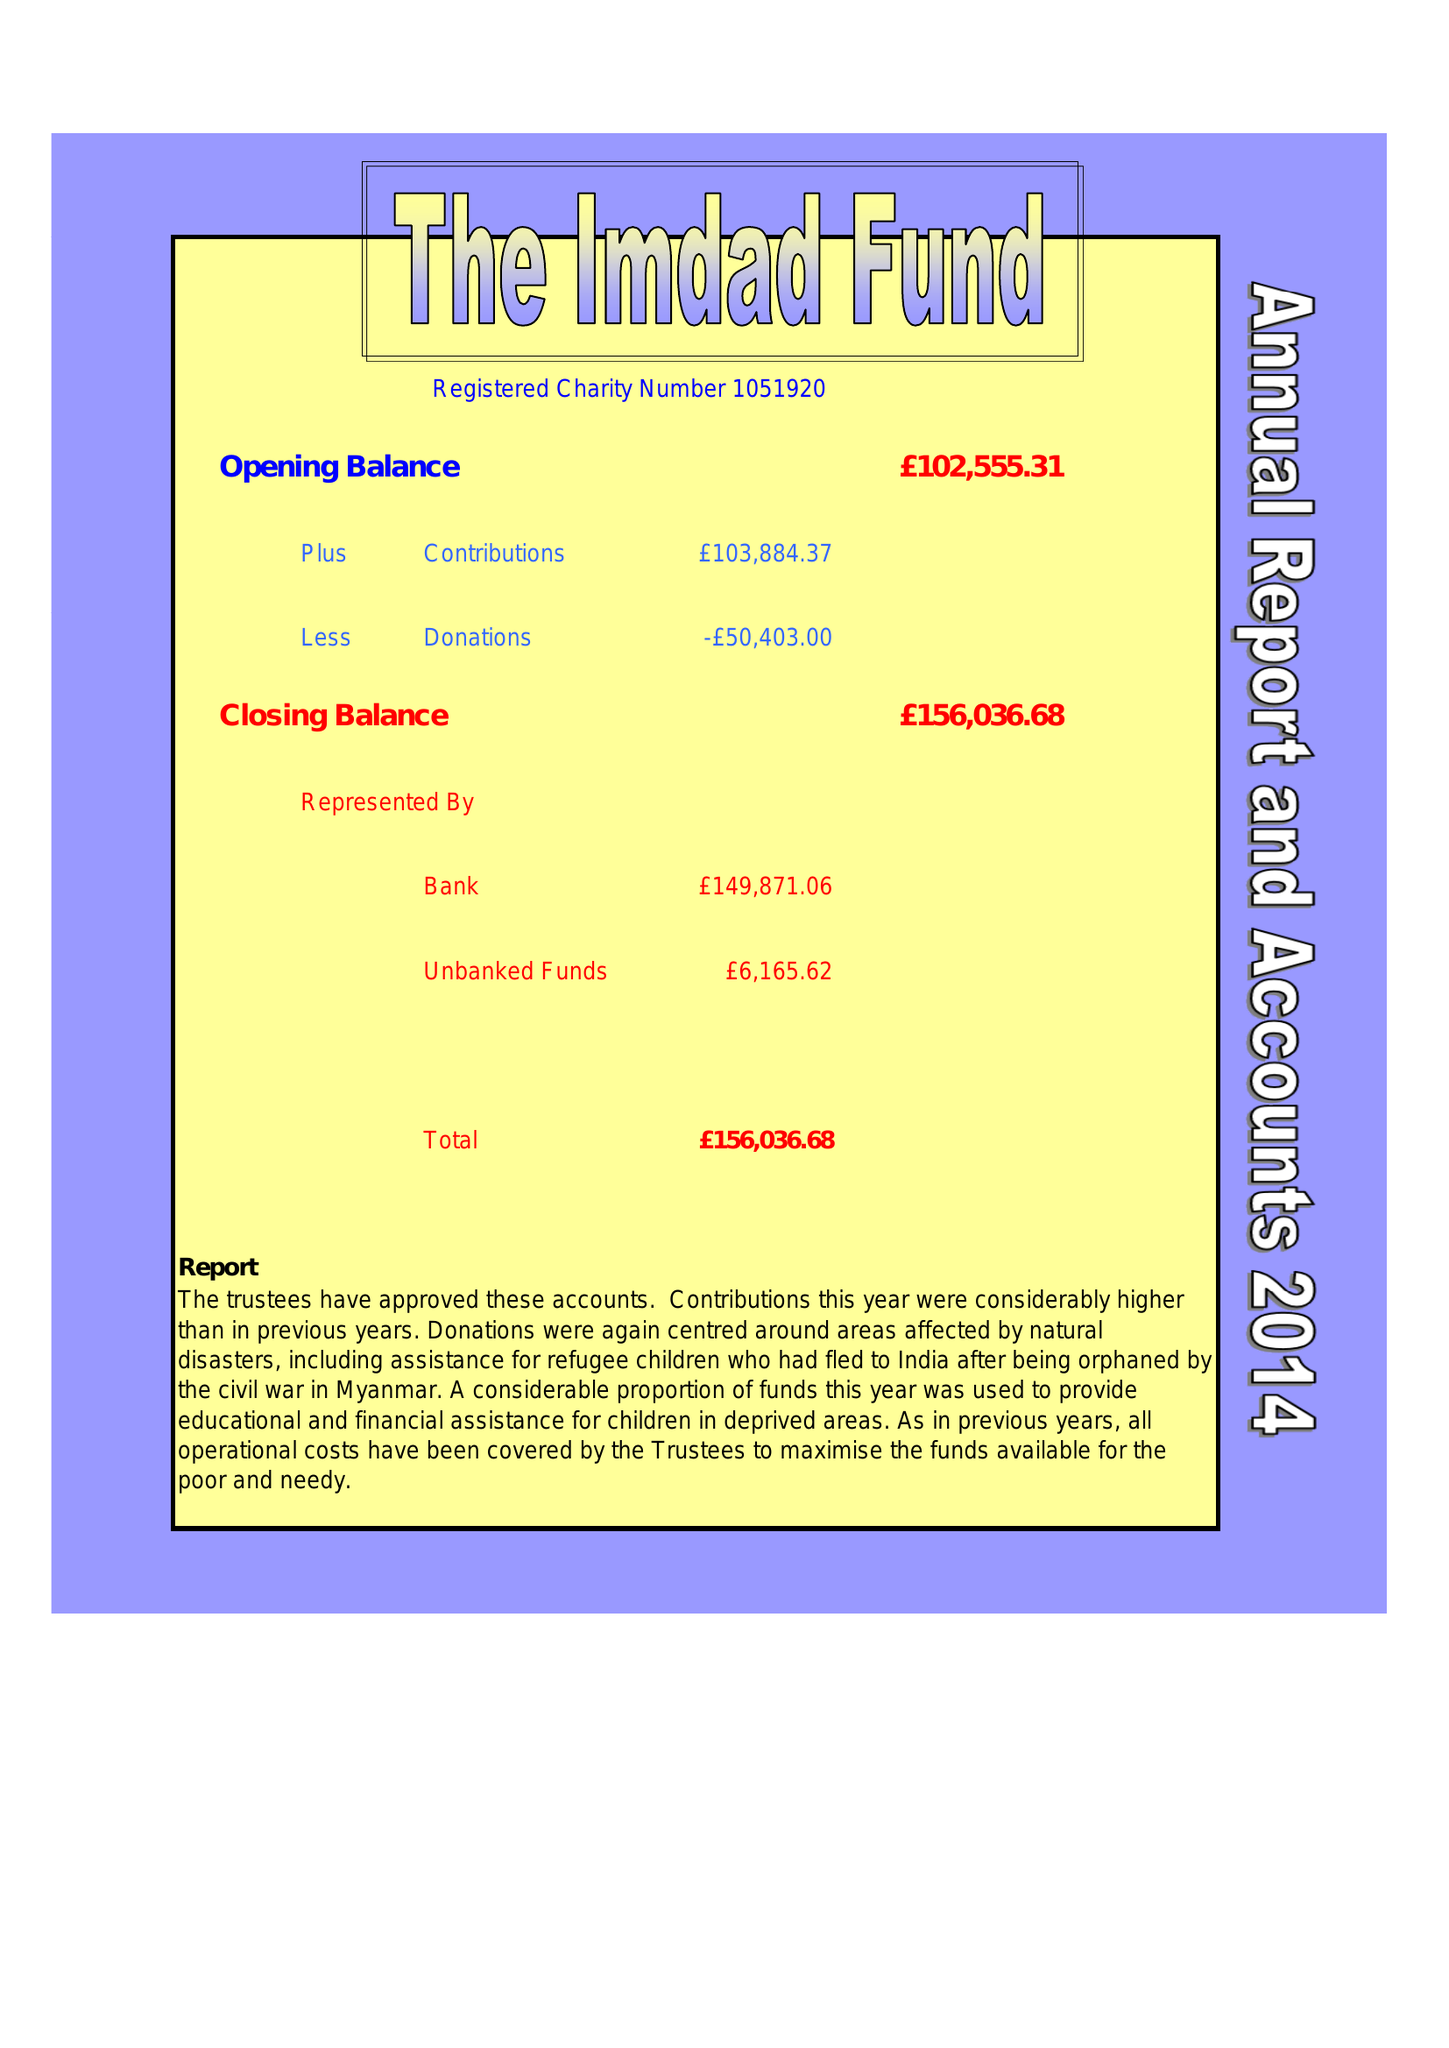What is the value for the charity_name?
Answer the question using a single word or phrase. The Imdad Fund 